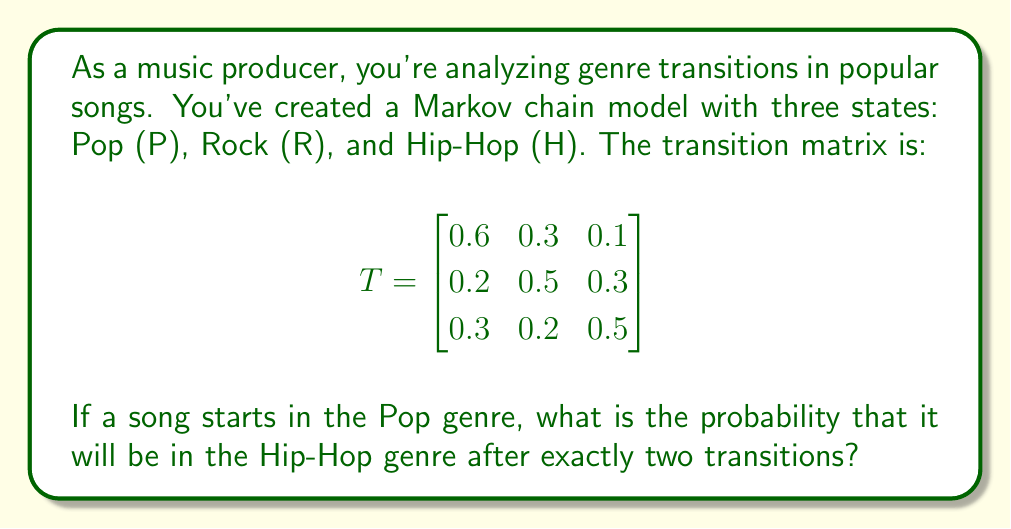What is the answer to this math problem? To solve this problem, we need to use the Markov chain transition matrix and calculate the probability of going from Pop to Hip-Hop in two steps. Let's break it down:

1. The initial state is Pop (P).
2. We need to find the probability of being in Hip-Hop (H) after two transitions.
3. This can be calculated by multiplying the transition matrix by itself and then looking at the appropriate entry.

Let's calculate $T^2$:

$$
T^2 = \begin{bmatrix}
0.6 & 0.3 & 0.1 \\
0.2 & 0.5 & 0.3 \\
0.3 & 0.2 & 0.5
\end{bmatrix} \times 
\begin{bmatrix}
0.6 & 0.3 & 0.1 \\
0.2 & 0.5 & 0.3 \\
0.3 & 0.2 & 0.5
\end{bmatrix}
$$

Multiplying these matrices:

$$
T^2 = \begin{bmatrix}
0.42 & 0.33 & 0.25 \\
0.33 & 0.38 & 0.29 \\
0.39 & 0.31 & 0.30
\end{bmatrix}
$$

The probability we're looking for is the entry in the first row (starting from Pop) and third column (ending in Hip-Hop) of $T^2$.

Therefore, the probability of starting in Pop and ending in Hip-Hop after two transitions is 0.25 or 25%.
Answer: 0.25 